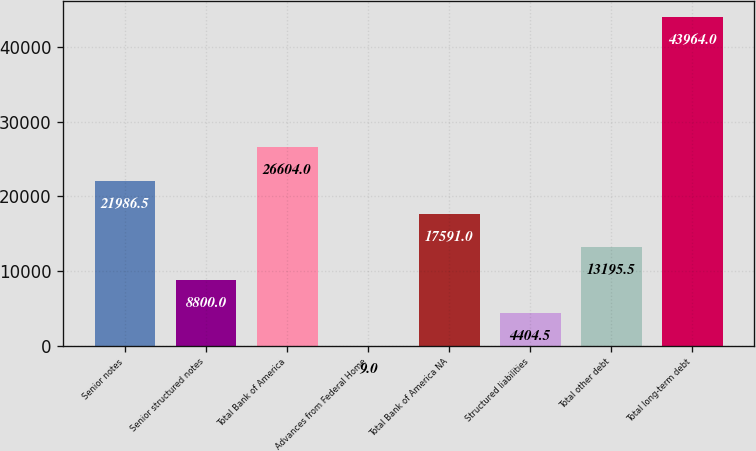Convert chart to OTSL. <chart><loc_0><loc_0><loc_500><loc_500><bar_chart><fcel>Senior notes<fcel>Senior structured notes<fcel>Total Bank of America<fcel>Advances from Federal Home<fcel>Total Bank of America NA<fcel>Structured liabilities<fcel>Total other debt<fcel>Total long-term debt<nl><fcel>21986.5<fcel>8800<fcel>26604<fcel>9<fcel>17591<fcel>4404.5<fcel>13195.5<fcel>43964<nl></chart> 